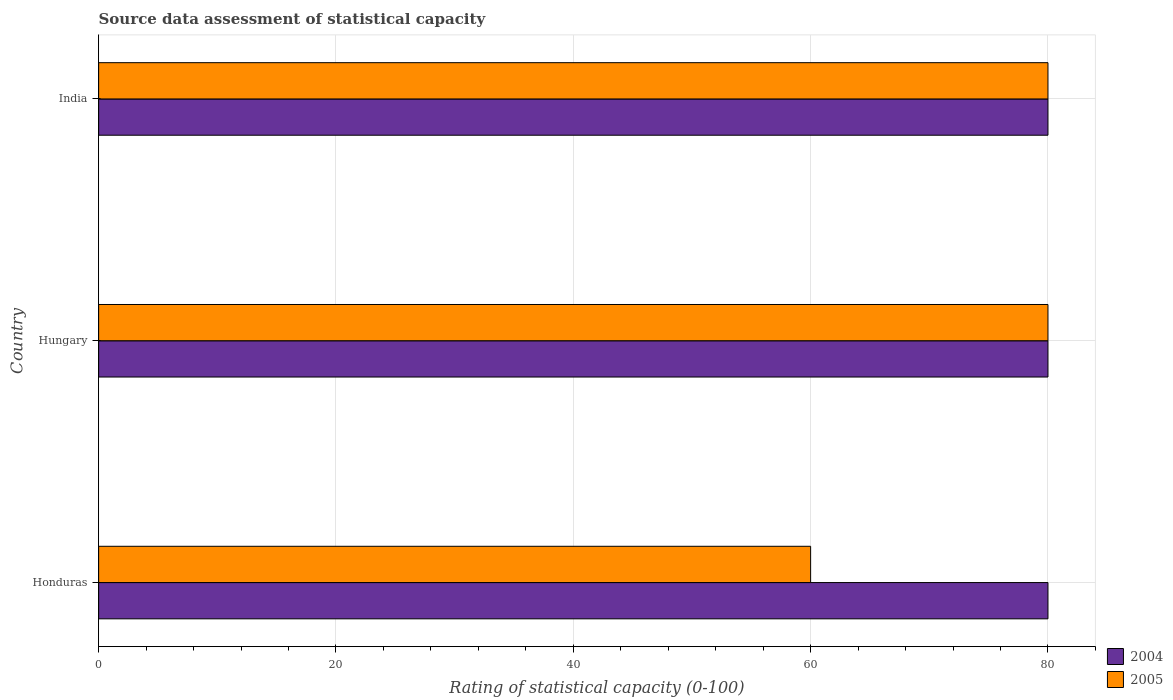How many groups of bars are there?
Offer a terse response. 3. Are the number of bars on each tick of the Y-axis equal?
Offer a terse response. Yes. How many bars are there on the 3rd tick from the top?
Provide a succinct answer. 2. What is the label of the 1st group of bars from the top?
Keep it short and to the point. India. Across all countries, what is the maximum rating of statistical capacity in 2005?
Make the answer very short. 80. Across all countries, what is the minimum rating of statistical capacity in 2004?
Your answer should be very brief. 80. In which country was the rating of statistical capacity in 2004 maximum?
Provide a short and direct response. Honduras. In which country was the rating of statistical capacity in 2004 minimum?
Offer a very short reply. Honduras. What is the total rating of statistical capacity in 2005 in the graph?
Give a very brief answer. 220. What is the difference between the rating of statistical capacity in 2005 in India and the rating of statistical capacity in 2004 in Hungary?
Provide a succinct answer. 0. Is the sum of the rating of statistical capacity in 2004 in Honduras and Hungary greater than the maximum rating of statistical capacity in 2005 across all countries?
Provide a short and direct response. Yes. What does the 2nd bar from the bottom in India represents?
Provide a short and direct response. 2005. Are all the bars in the graph horizontal?
Give a very brief answer. Yes. How many countries are there in the graph?
Offer a terse response. 3. Are the values on the major ticks of X-axis written in scientific E-notation?
Give a very brief answer. No. How many legend labels are there?
Your answer should be very brief. 2. What is the title of the graph?
Your answer should be compact. Source data assessment of statistical capacity. Does "1960" appear as one of the legend labels in the graph?
Make the answer very short. No. What is the label or title of the X-axis?
Your answer should be very brief. Rating of statistical capacity (0-100). What is the Rating of statistical capacity (0-100) of 2005 in Honduras?
Offer a terse response. 60. What is the Rating of statistical capacity (0-100) in 2004 in India?
Give a very brief answer. 80. What is the Rating of statistical capacity (0-100) of 2005 in India?
Keep it short and to the point. 80. Across all countries, what is the minimum Rating of statistical capacity (0-100) of 2004?
Ensure brevity in your answer.  80. Across all countries, what is the minimum Rating of statistical capacity (0-100) in 2005?
Offer a terse response. 60. What is the total Rating of statistical capacity (0-100) of 2004 in the graph?
Offer a terse response. 240. What is the total Rating of statistical capacity (0-100) of 2005 in the graph?
Offer a terse response. 220. What is the difference between the Rating of statistical capacity (0-100) of 2005 in Honduras and that in Hungary?
Ensure brevity in your answer.  -20. What is the difference between the Rating of statistical capacity (0-100) of 2004 in Honduras and that in India?
Make the answer very short. 0. What is the difference between the Rating of statistical capacity (0-100) of 2004 in Honduras and the Rating of statistical capacity (0-100) of 2005 in Hungary?
Offer a terse response. 0. What is the difference between the Rating of statistical capacity (0-100) in 2004 in Hungary and the Rating of statistical capacity (0-100) in 2005 in India?
Ensure brevity in your answer.  0. What is the average Rating of statistical capacity (0-100) in 2005 per country?
Give a very brief answer. 73.33. What is the difference between the Rating of statistical capacity (0-100) in 2004 and Rating of statistical capacity (0-100) in 2005 in Honduras?
Offer a terse response. 20. What is the difference between the Rating of statistical capacity (0-100) in 2004 and Rating of statistical capacity (0-100) in 2005 in Hungary?
Your answer should be very brief. 0. What is the difference between the Rating of statistical capacity (0-100) of 2004 and Rating of statistical capacity (0-100) of 2005 in India?
Keep it short and to the point. 0. What is the ratio of the Rating of statistical capacity (0-100) in 2005 in Honduras to that in Hungary?
Ensure brevity in your answer.  0.75. What is the ratio of the Rating of statistical capacity (0-100) of 2005 in Honduras to that in India?
Your answer should be compact. 0.75. What is the ratio of the Rating of statistical capacity (0-100) in 2004 in Hungary to that in India?
Make the answer very short. 1. What is the ratio of the Rating of statistical capacity (0-100) of 2005 in Hungary to that in India?
Offer a terse response. 1. What is the difference between the highest and the second highest Rating of statistical capacity (0-100) in 2004?
Give a very brief answer. 0. What is the difference between the highest and the lowest Rating of statistical capacity (0-100) in 2005?
Ensure brevity in your answer.  20. 